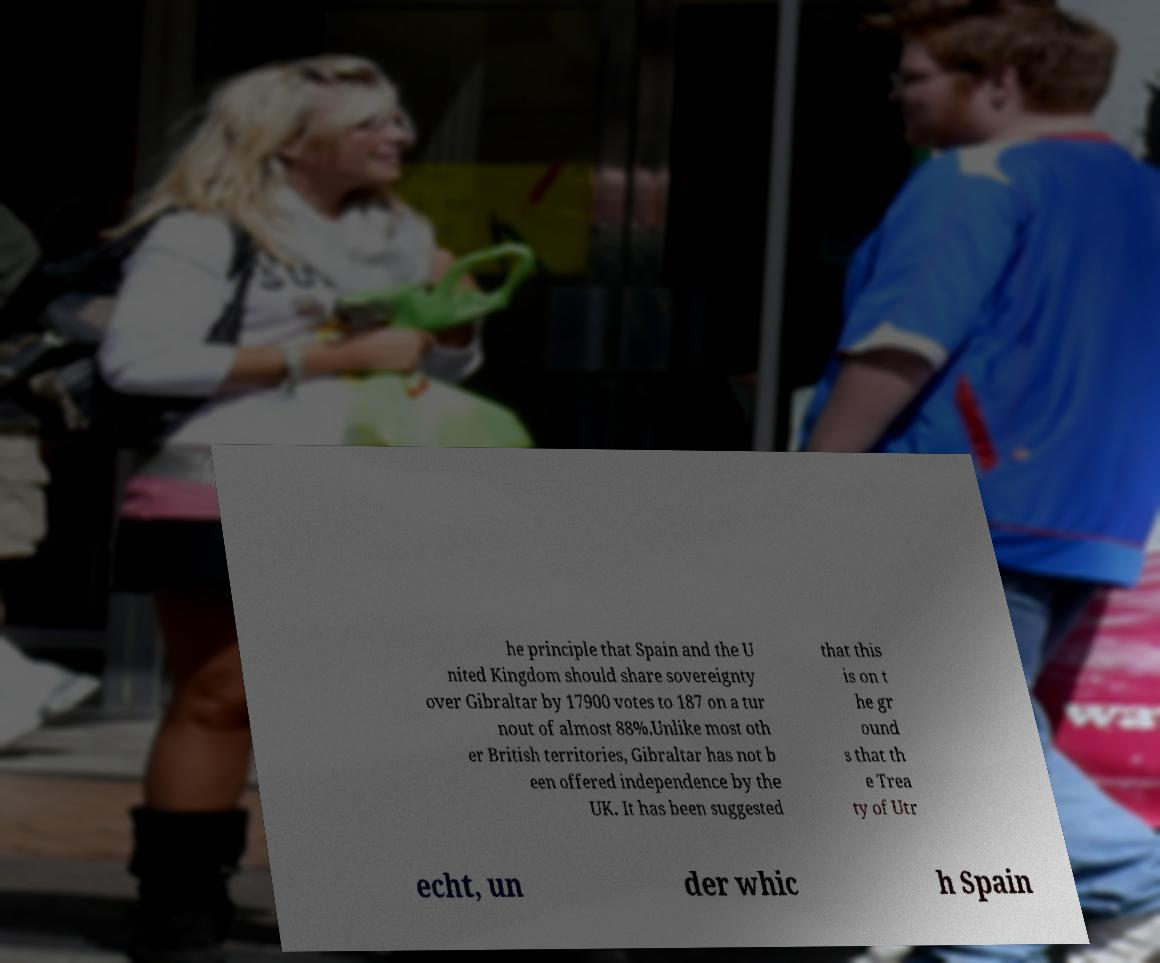Can you read and provide the text displayed in the image?This photo seems to have some interesting text. Can you extract and type it out for me? he principle that Spain and the U nited Kingdom should share sovereignty over Gibraltar by 17900 votes to 187 on a tur nout of almost 88%.Unlike most oth er British territories, Gibraltar has not b een offered independence by the UK. It has been suggested that this is on t he gr ound s that th e Trea ty of Utr echt, un der whic h Spain 